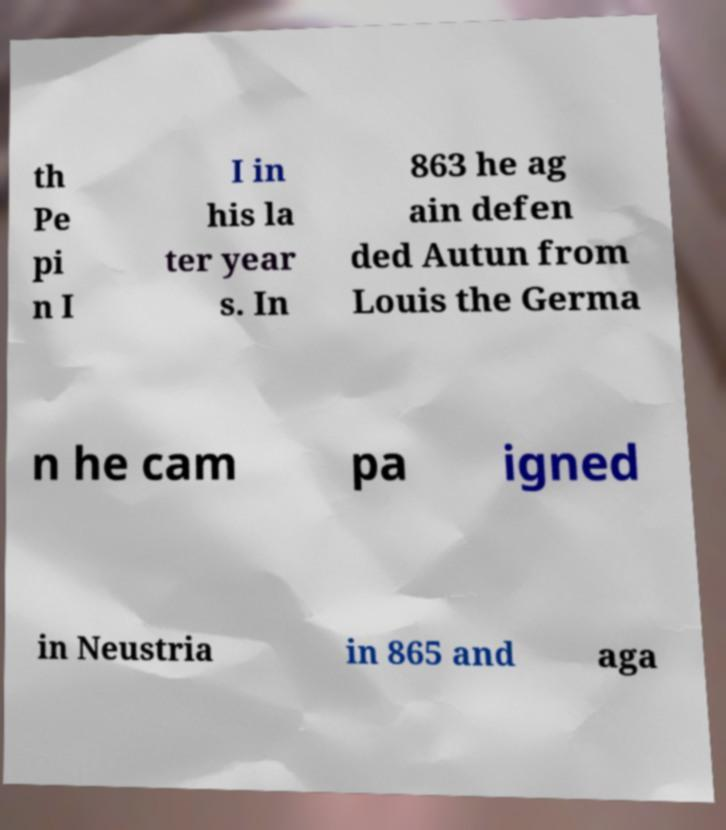Please read and relay the text visible in this image. What does it say? th Pe pi n I I in his la ter year s. In 863 he ag ain defen ded Autun from Louis the Germa n he cam pa igned in Neustria in 865 and aga 